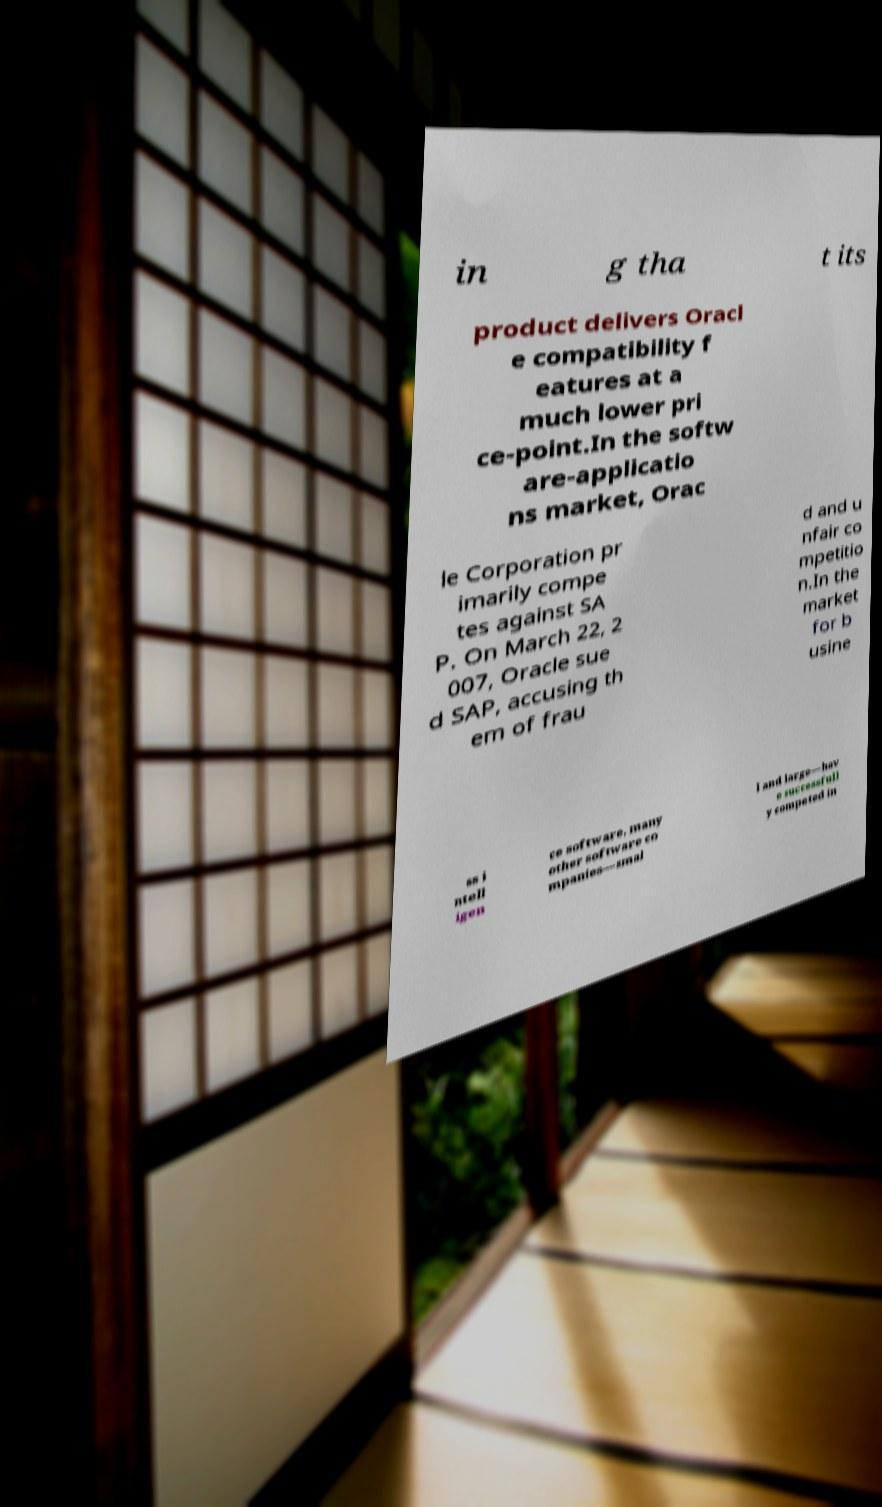Could you assist in decoding the text presented in this image and type it out clearly? in g tha t its product delivers Oracl e compatibility f eatures at a much lower pri ce-point.In the softw are-applicatio ns market, Orac le Corporation pr imarily compe tes against SA P. On March 22, 2 007, Oracle sue d SAP, accusing th em of frau d and u nfair co mpetitio n.In the market for b usine ss i ntell igen ce software, many other software co mpanies—smal l and large—hav e successfull y competed in 